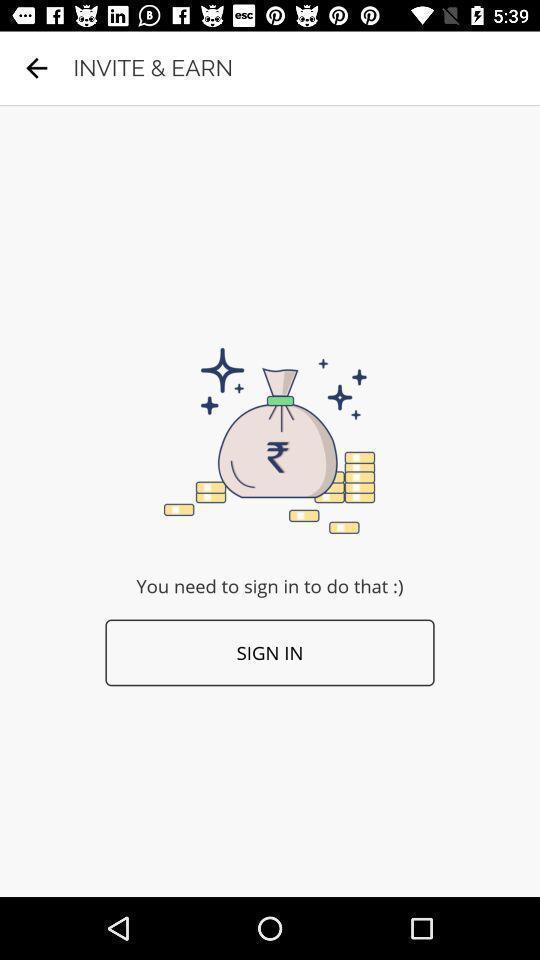Describe the visual elements of this screenshot. Sign in page of a financial app. 